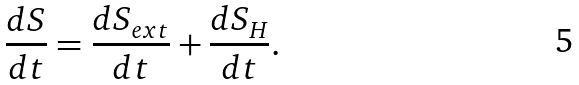Convert formula to latex. <formula><loc_0><loc_0><loc_500><loc_500>\frac { d S } { d t } = \frac { d S _ { e x t } } { d t } + \frac { d S _ { H } } { d t } .</formula> 